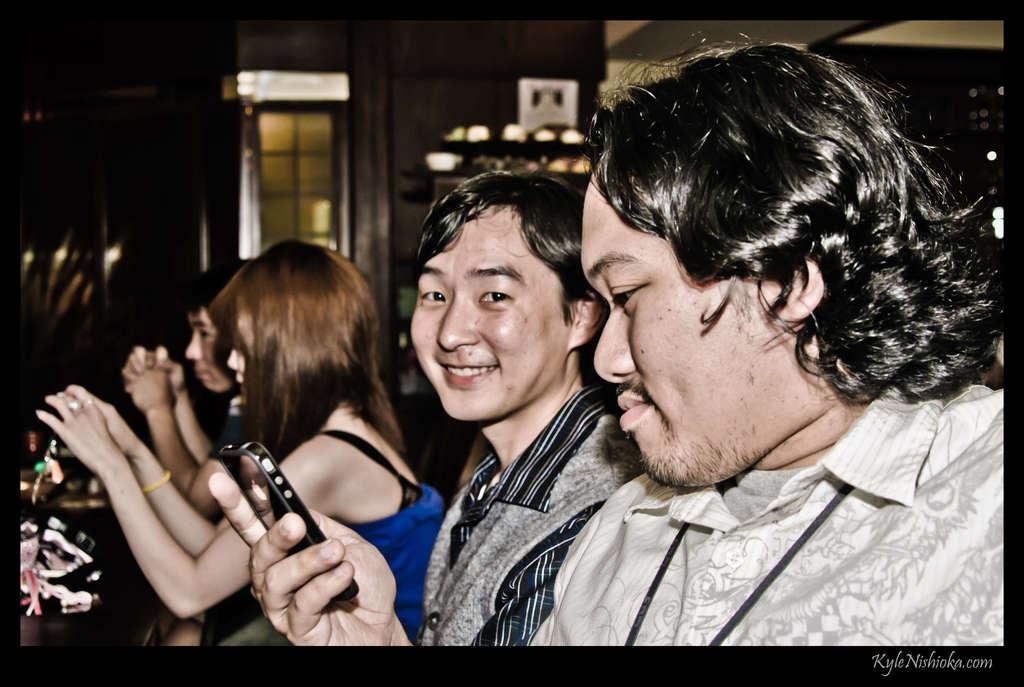Who is present in the image? There are people in the image. What are the people doing in the image? The people are sitting. What objects are the people holding in their hands? The people are holding mobile devices in their hands. What type of property can be seen in the image? There is no property visible in the image; it features people sitting and holding mobile devices. How many beans are present in the image? There are no beans present in the image. 